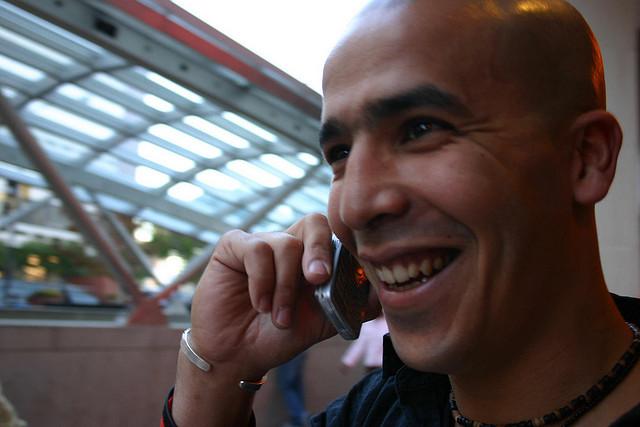What happened to his hair?
Quick response, please. Shaved. Is that kind of necklace still in fashion?
Be succinct. No. What color is the vehicle behind the fence?
Give a very brief answer. White. Is he wearing glasses?
Keep it brief. No. What is he talking on?
Quick response, please. Cell phone. 